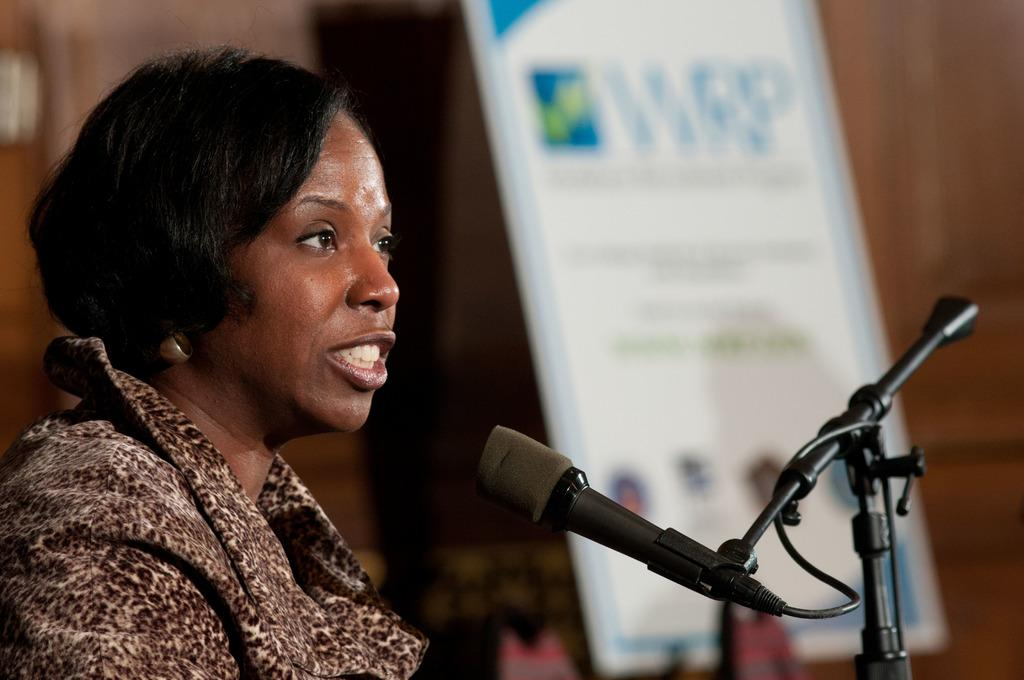Who is the main subject in the image? There is a lady in the image. Where is the lady located in the image? The lady is on the left side of the image. What object is in front of the lady? There is a microphone in front of the lady. What can be seen in the background of the image? There is a poster in the background of the image. What type of organization is the lady affiliated with in the image? There is no information about the lady's affiliation or any organization in the image. 